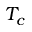<formula> <loc_0><loc_0><loc_500><loc_500>T _ { c }</formula> 